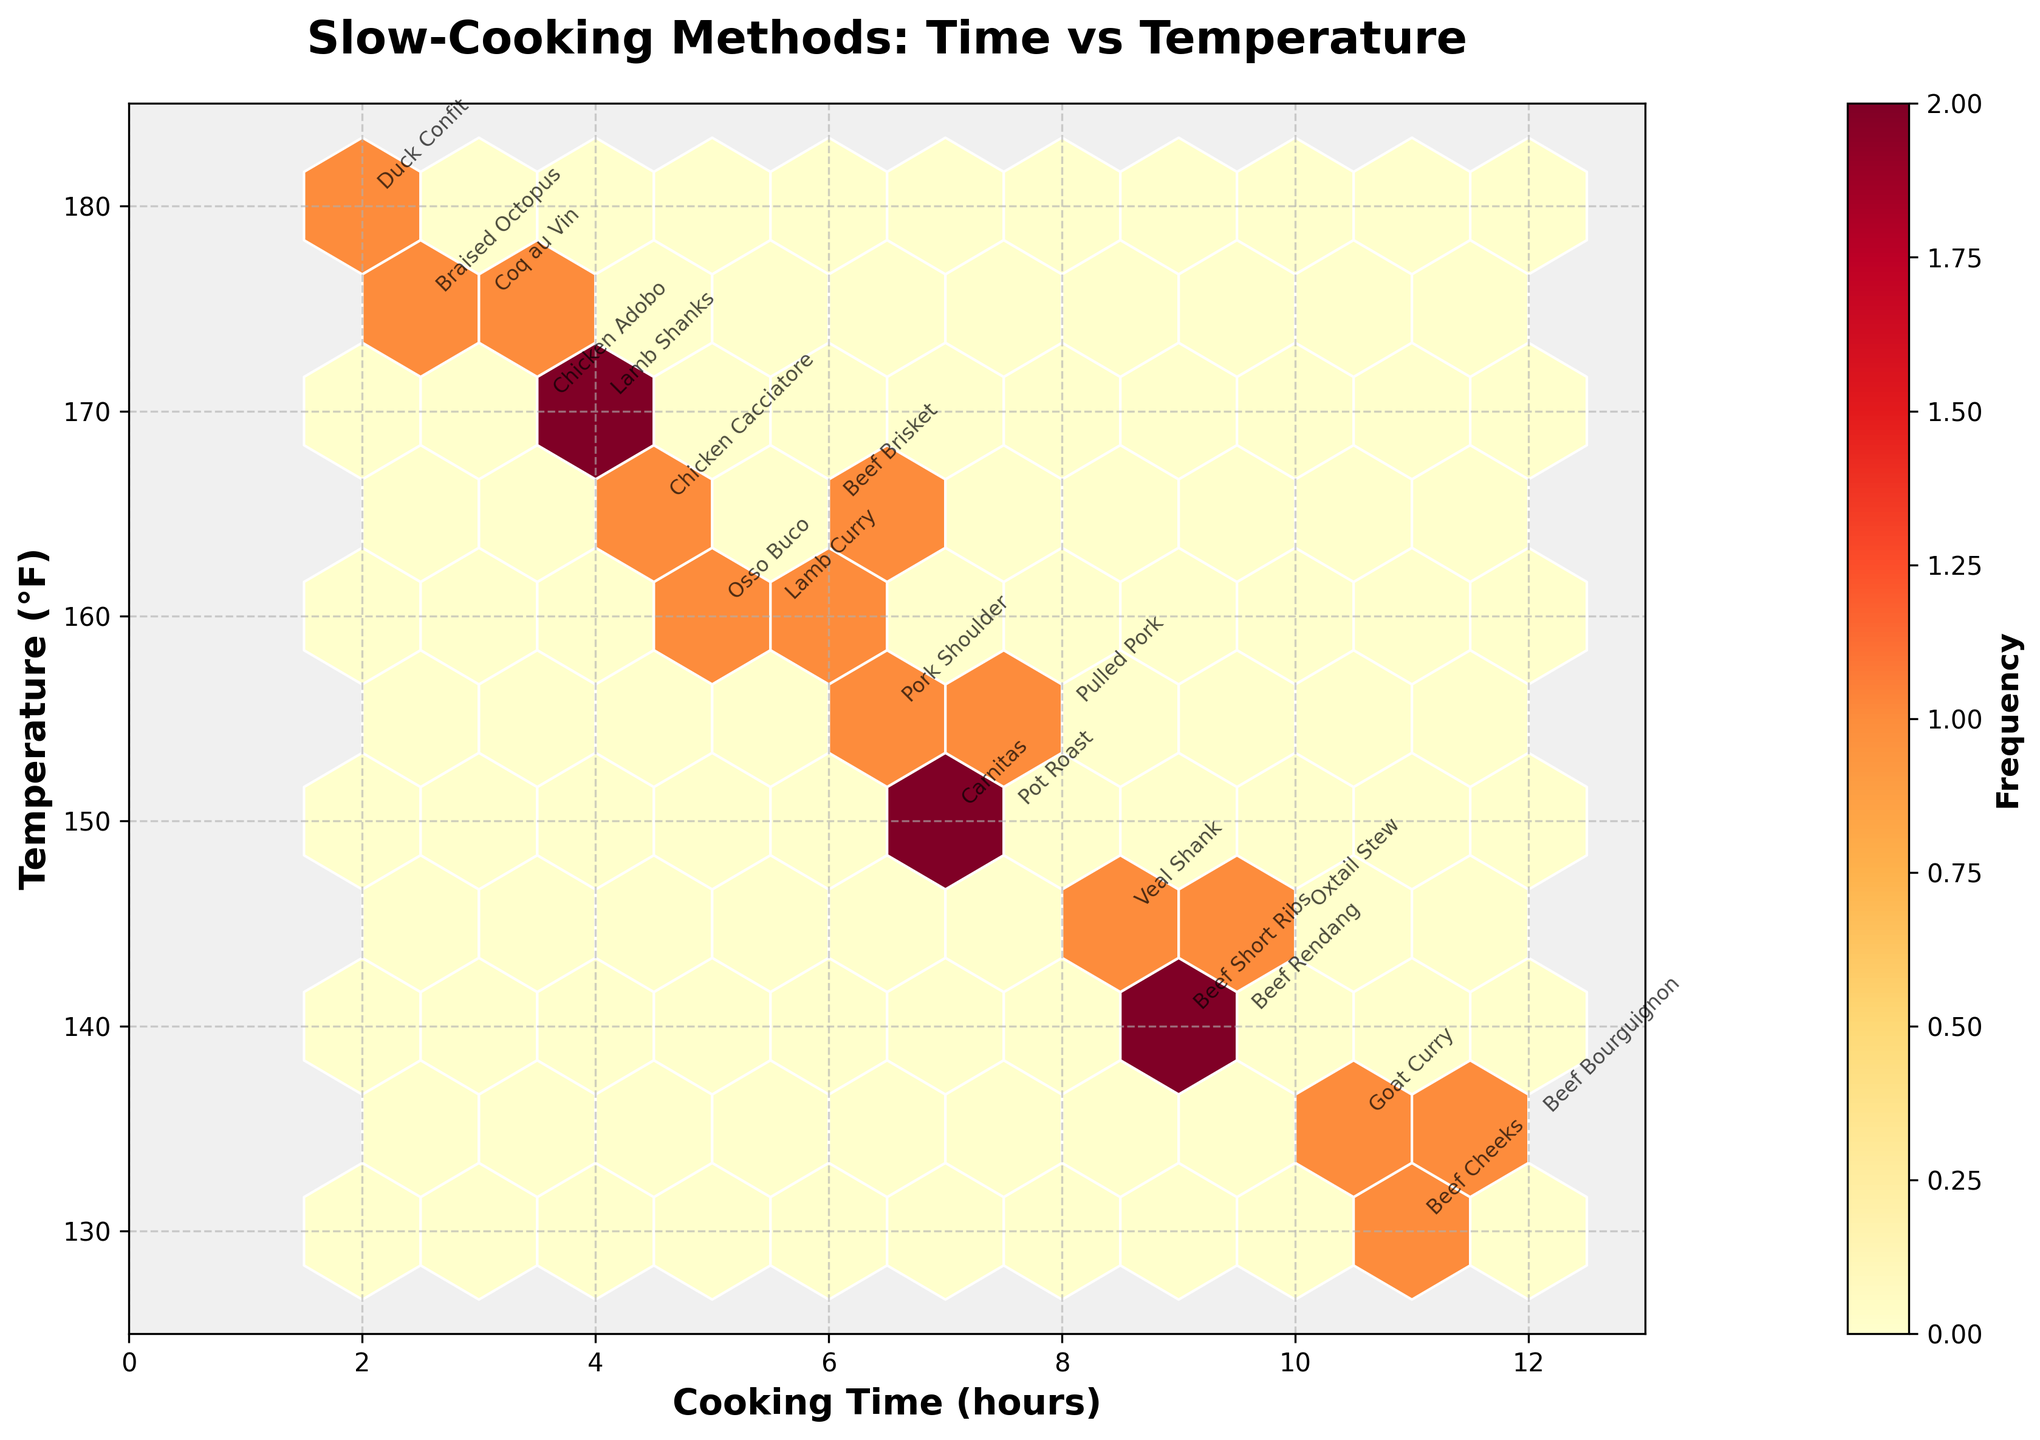What's the title of the figure? The title of the figure is displayed at the top and is usually the largest and boldest text.
Answer: Slow-Cooking Methods: Time vs Temperature What are the labels of the X and Y axes? The labels are located along the X and Y axes, respectively.
Answer: Cooking Time (hours) and Temperature (°F) What's the color gradient used for the hexbin plot? The color gradient can be seen from the color bar, which shows yellow to orange to red indicating changes in frequency.
Answer: Yellow-Orange-Red gradient Which dish has the highest cooking temperature? Look for the highest point along the Y-axis and identify the annotated dish at that location.
Answer: Duck Confit Which dish has the longest cooking time? Look for the furthest point to the right along the X-axis and identify the annotated dish at that location.
Answer: Beef Bourguignon What is the correlation between cooking time and temperature? Observe the overall trend of the data points in the plot. If the data points tend to rise or fall together, it shows correlation.
Answer: Negative correlation What's the range of the cooking times displayed? Identify the minimum and maximum values along the X-axis where data points are present.
Answer: 2 to 12 hours What's the dish cooked at a temperature of 150°F for 7.5 hours? Locate the point where X = 7.5 and Y = 150, and identify the annotated dish.
Answer: Pot Roast What is the average cooking temperature for dishes cooked for more than 8 hours? Identify the dishes that meet the time criterion, sum the temperatures of these dishes, and divide by the number of these dishes.
Answer: 137.5°F Which dishes are cooked at 165°F, and what are their cooking times? Look for points with Y = 165 and identify the annotated dishes, considering their respective cooking times on the X-axis.
Answer: Beef Brisket (6 hours), Chicken Cacciatore (4.5 hours) 